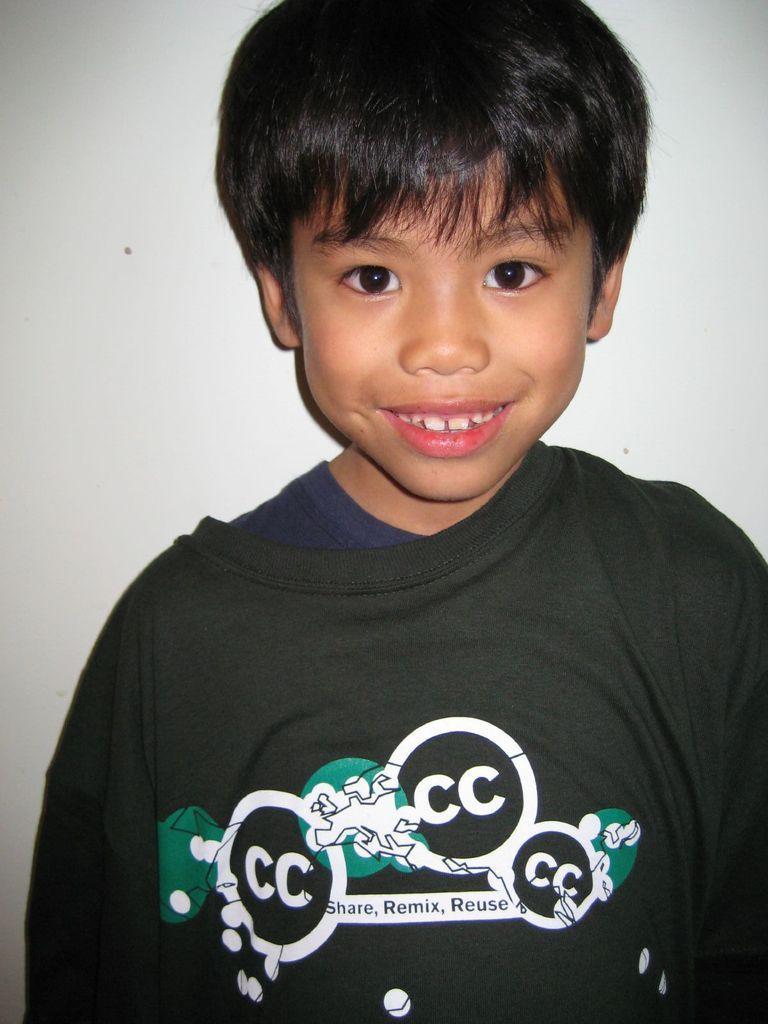Can you describe this image briefly? In the front of the image I can see a boy is smiling. In the background of the image it is in white color.   